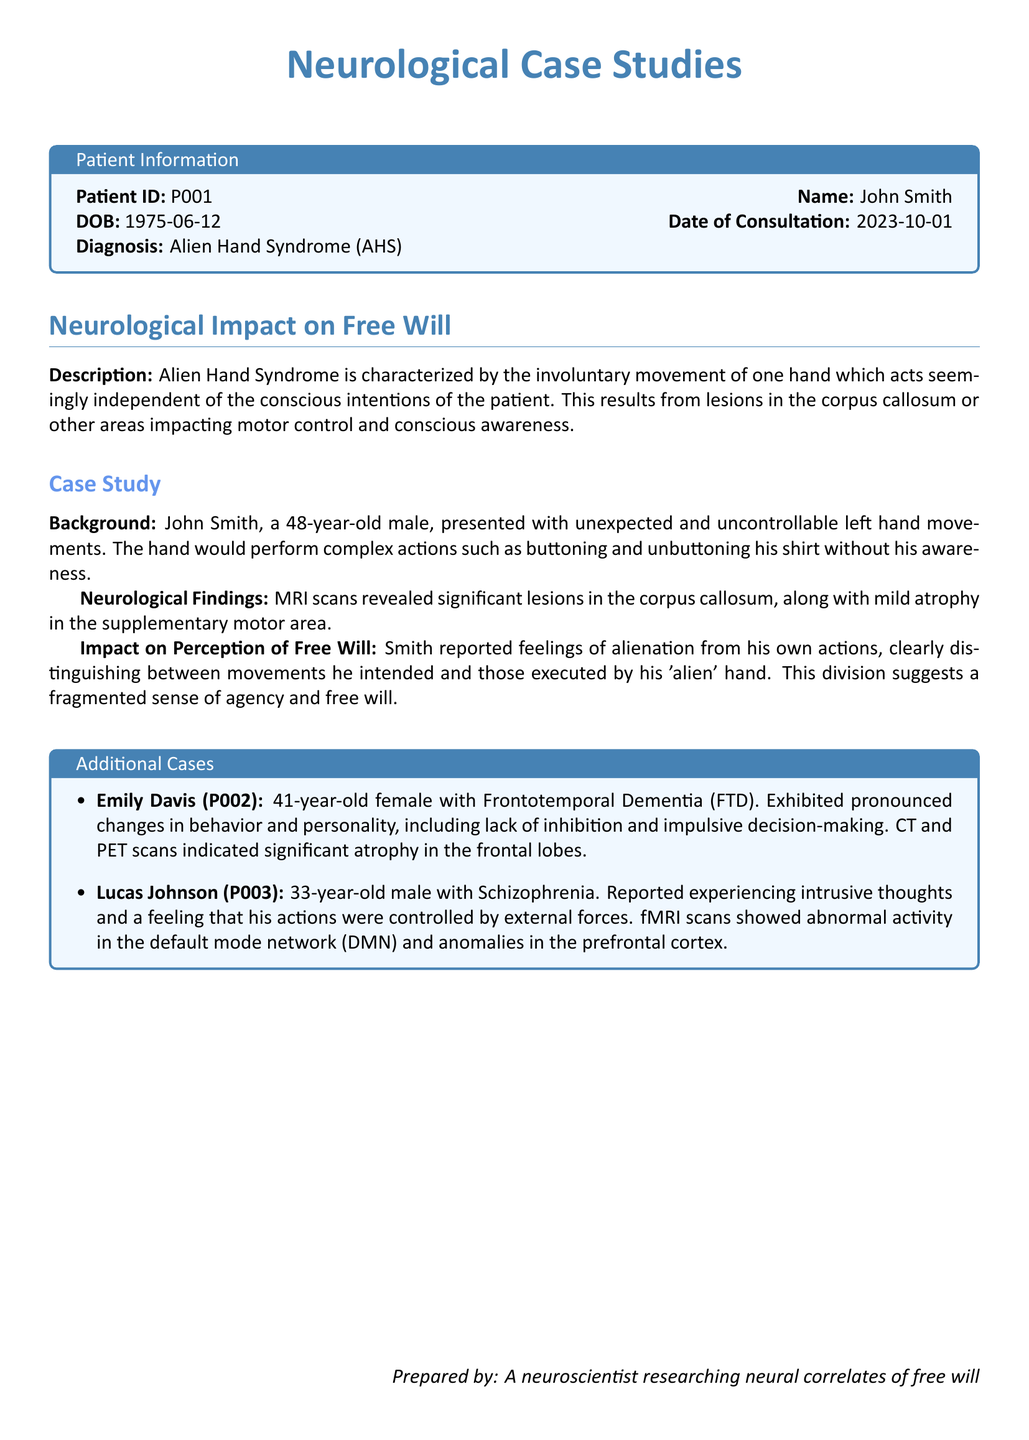What is the patient ID for John Smith? The patient ID is specifically listed in the patient information section of the document.
Answer: P001 What is the date of consultation for John Smith? The date of consultation is provided in the patient information section of the document.
Answer: 2023-10-01 What syndrome is John Smith diagnosed with? The diagnosis for John Smith is clearly stated in the patient information box of the document.
Answer: Alien Hand Syndrome What area of the brain showed lesions in John Smith? The document mentions specific neurological findings in relation to the patient’s condition.
Answer: Corpus callosum What behavioral changes are noted in Emily Davis? The document describes specific symptoms and changes in behavior for Emily Davis under additional cases.
Answer: Lack of inhibition How old is Lucas Johnson? The age of Lucas Johnson is mentioned in the additional cases section of the document.
Answer: 33 What type of dementia does Emily Davis have? The document lists the specific type of dementia in the additional cases section.
Answer: Frontotemporal Dementia What feelings did John Smith report about his actions? The document discusses John Smith's perception of his actions, indicating a specific feeling.
Answer: Alienation What type of scan revealed abnormalities in Lucas Johnson? The type of scans used to investigate Lucas Johnson's condition is noted in the additional cases.
Answer: fMRI scans 